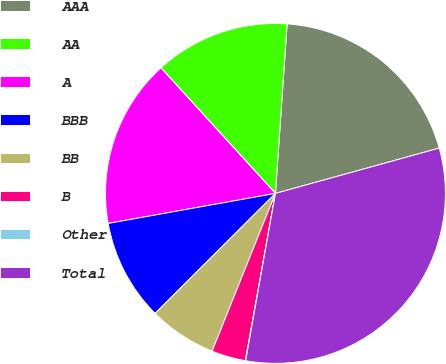Convert chart to OTSL. <chart><loc_0><loc_0><loc_500><loc_500><pie_chart><fcel>AAA<fcel>AA<fcel>A<fcel>BBB<fcel>BB<fcel>B<fcel>Other<fcel>Total<nl><fcel>19.61%<fcel>12.86%<fcel>16.06%<fcel>9.65%<fcel>6.45%<fcel>3.24%<fcel>0.03%<fcel>32.1%<nl></chart> 